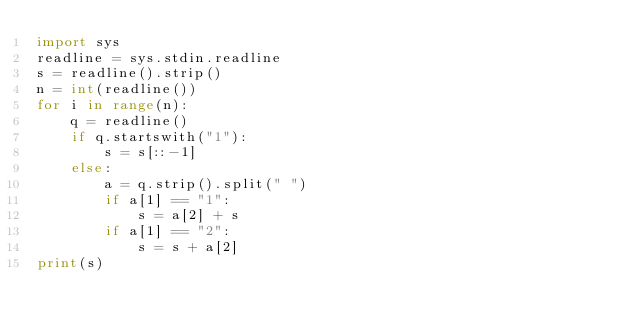<code> <loc_0><loc_0><loc_500><loc_500><_Python_>import sys
readline = sys.stdin.readline
s = readline().strip()
n = int(readline())
for i in range(n):
    q = readline()
    if q.startswith("1"):
        s = s[::-1]
    else:
        a = q.strip().split(" ")
        if a[1] == "1":
            s = a[2] + s
        if a[1] == "2":
            s = s + a[2]
print(s)
</code> 